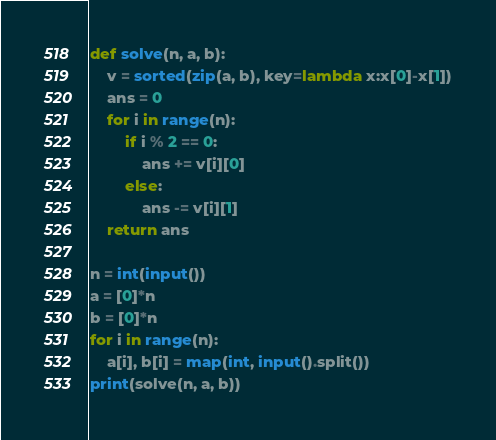Convert code to text. <code><loc_0><loc_0><loc_500><loc_500><_Python_>def solve(n, a, b):
    v = sorted(zip(a, b), key=lambda x:x[0]-x[1])
    ans = 0
    for i in range(n):
        if i % 2 == 0:
            ans += v[i][0]
        else:
            ans -= v[i][1]
    return ans

n = int(input())
a = [0]*n
b = [0]*n
for i in range(n):
    a[i], b[i] = map(int, input().split())
print(solve(n, a, b))</code> 